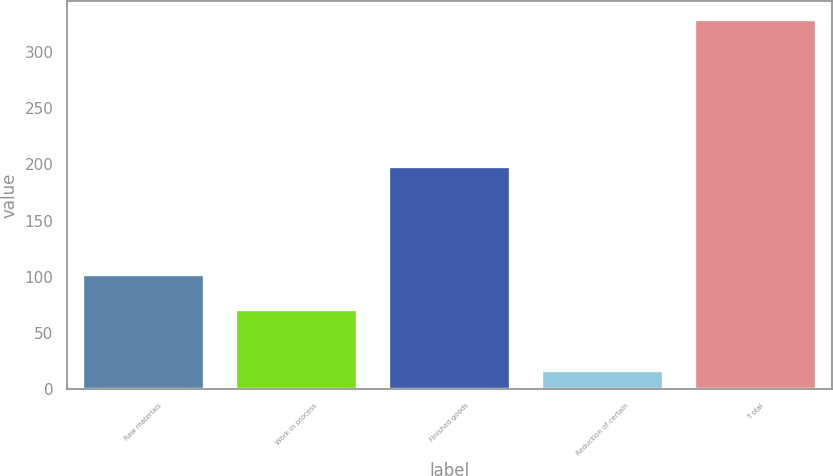<chart> <loc_0><loc_0><loc_500><loc_500><bar_chart><fcel>Raw materials<fcel>Work in process<fcel>Finished goods<fcel>Reduction of certain<fcel>T otal<nl><fcel>102.52<fcel>71.3<fcel>198.4<fcel>17.2<fcel>329.4<nl></chart> 